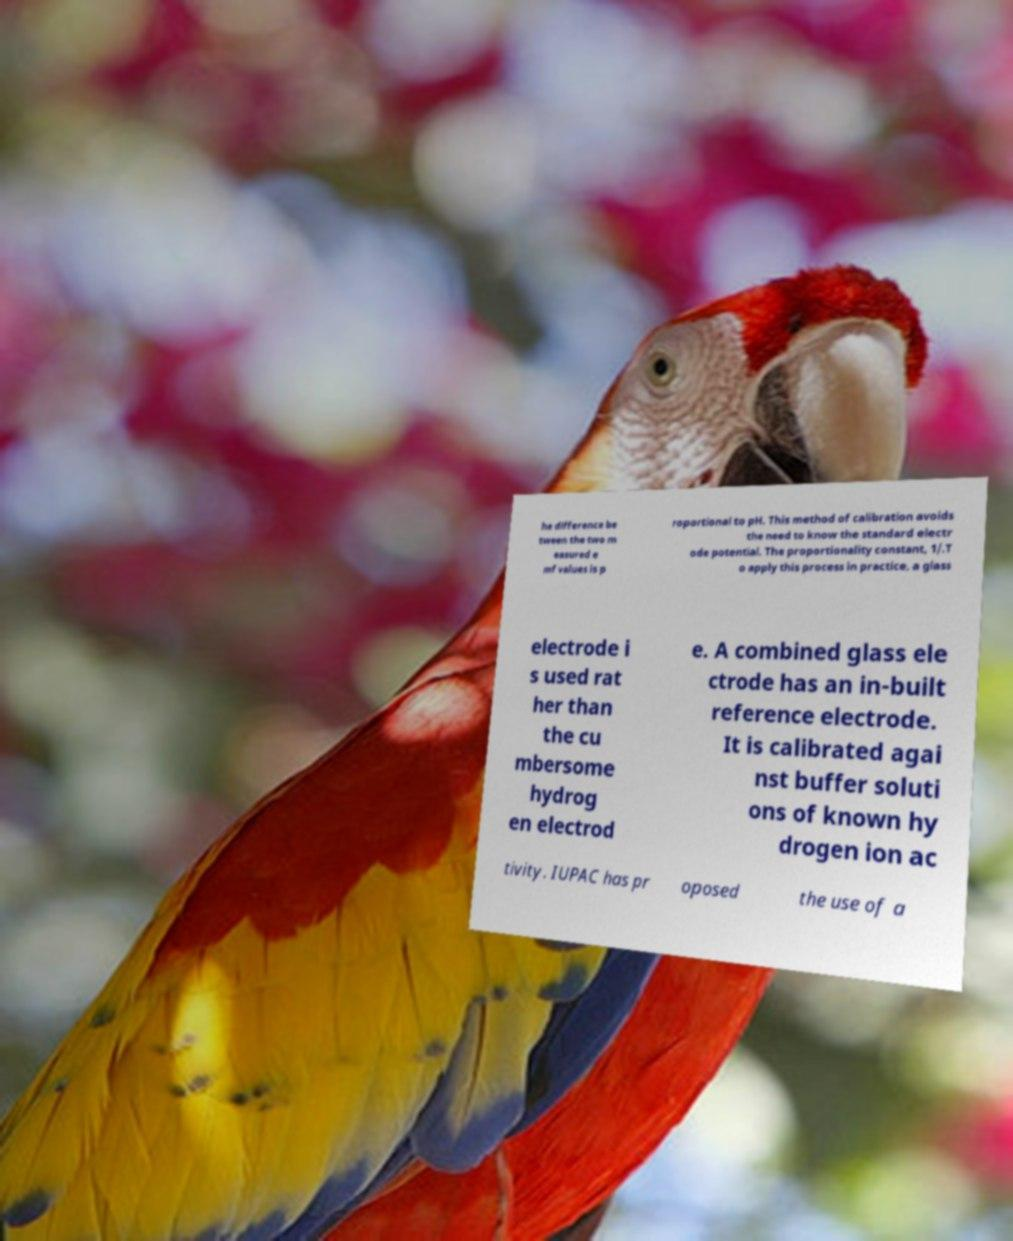Please read and relay the text visible in this image. What does it say? he difference be tween the two m easured e mf values is p roportional to pH. This method of calibration avoids the need to know the standard electr ode potential. The proportionality constant, 1/.T o apply this process in practice, a glass electrode i s used rat her than the cu mbersome hydrog en electrod e. A combined glass ele ctrode has an in-built reference electrode. It is calibrated agai nst buffer soluti ons of known hy drogen ion ac tivity. IUPAC has pr oposed the use of a 